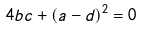Convert formula to latex. <formula><loc_0><loc_0><loc_500><loc_500>4 b c + ( a - d ) ^ { 2 } = 0</formula> 